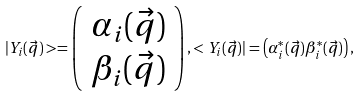<formula> <loc_0><loc_0><loc_500><loc_500>| Y _ { i } ( \vec { q } ) > = \left ( \begin{array} { c } \alpha _ { i } ( \vec { q } ) \\ \beta _ { i } ( \vec { q } ) \end{array} \right ) , < Y _ { i } ( \vec { q } ) | = \left ( \alpha ^ { \ast } _ { i } ( \vec { q } ) \beta ^ { \ast } _ { i } ( \vec { q } ) \right ) ,</formula> 